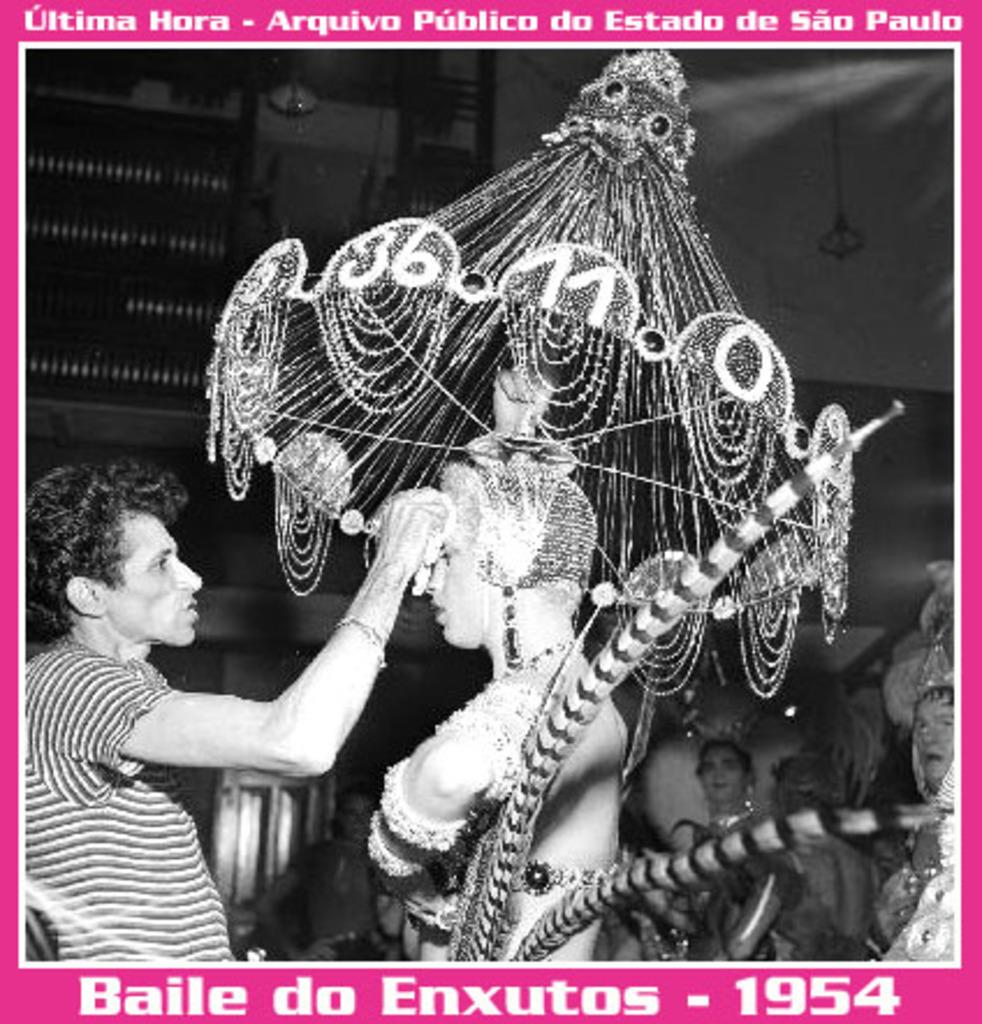What is featured on the poster in the image? The poster contains a group of people. Can you describe the person in the middle of the image? The person in the middle of the image is wearing a costume. What is the main subject of the image? The main subject of the image is a person wearing a costume. What type of knife is being used to make a statement on the poster? There is no knife or statement being made on the poster; it features a group of people and a person wearing a costume. 